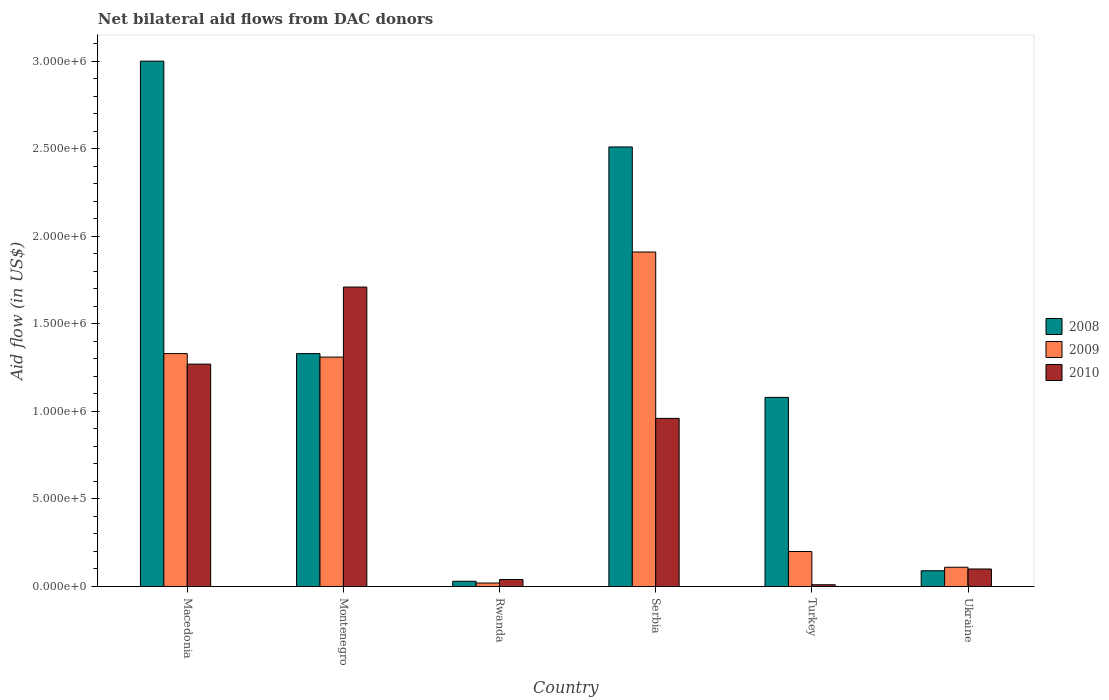How many different coloured bars are there?
Provide a succinct answer. 3. Are the number of bars on each tick of the X-axis equal?
Provide a succinct answer. Yes. How many bars are there on the 2nd tick from the left?
Provide a short and direct response. 3. What is the label of the 5th group of bars from the left?
Your answer should be very brief. Turkey. In how many cases, is the number of bars for a given country not equal to the number of legend labels?
Offer a very short reply. 0. Across all countries, what is the maximum net bilateral aid flow in 2009?
Your answer should be compact. 1.91e+06. Across all countries, what is the minimum net bilateral aid flow in 2009?
Your answer should be compact. 2.00e+04. In which country was the net bilateral aid flow in 2008 maximum?
Make the answer very short. Macedonia. What is the total net bilateral aid flow in 2010 in the graph?
Keep it short and to the point. 4.09e+06. What is the difference between the net bilateral aid flow in 2008 in Macedonia and that in Turkey?
Ensure brevity in your answer.  1.92e+06. What is the difference between the net bilateral aid flow in 2008 in Ukraine and the net bilateral aid flow in 2009 in Serbia?
Provide a succinct answer. -1.82e+06. What is the average net bilateral aid flow in 2008 per country?
Your answer should be very brief. 1.34e+06. What is the difference between the net bilateral aid flow of/in 2009 and net bilateral aid flow of/in 2008 in Rwanda?
Your answer should be very brief. -10000. In how many countries, is the net bilateral aid flow in 2009 greater than 700000 US$?
Offer a terse response. 3. What is the ratio of the net bilateral aid flow in 2009 in Rwanda to that in Ukraine?
Provide a succinct answer. 0.18. What is the difference between the highest and the second highest net bilateral aid flow in 2008?
Your answer should be very brief. 1.67e+06. What is the difference between the highest and the lowest net bilateral aid flow in 2009?
Provide a short and direct response. 1.89e+06. In how many countries, is the net bilateral aid flow in 2010 greater than the average net bilateral aid flow in 2010 taken over all countries?
Keep it short and to the point. 3. Is the sum of the net bilateral aid flow in 2008 in Montenegro and Serbia greater than the maximum net bilateral aid flow in 2009 across all countries?
Your response must be concise. Yes. What does the 3rd bar from the right in Macedonia represents?
Make the answer very short. 2008. Is it the case that in every country, the sum of the net bilateral aid flow in 2008 and net bilateral aid flow in 2010 is greater than the net bilateral aid flow in 2009?
Keep it short and to the point. Yes. How many bars are there?
Offer a terse response. 18. How many countries are there in the graph?
Keep it short and to the point. 6. What is the difference between two consecutive major ticks on the Y-axis?
Provide a succinct answer. 5.00e+05. Does the graph contain any zero values?
Offer a very short reply. No. Where does the legend appear in the graph?
Offer a very short reply. Center right. How many legend labels are there?
Your response must be concise. 3. How are the legend labels stacked?
Make the answer very short. Vertical. What is the title of the graph?
Make the answer very short. Net bilateral aid flows from DAC donors. Does "1975" appear as one of the legend labels in the graph?
Give a very brief answer. No. What is the label or title of the X-axis?
Provide a succinct answer. Country. What is the label or title of the Y-axis?
Your answer should be very brief. Aid flow (in US$). What is the Aid flow (in US$) of 2008 in Macedonia?
Provide a short and direct response. 3.00e+06. What is the Aid flow (in US$) of 2009 in Macedonia?
Provide a succinct answer. 1.33e+06. What is the Aid flow (in US$) in 2010 in Macedonia?
Provide a short and direct response. 1.27e+06. What is the Aid flow (in US$) in 2008 in Montenegro?
Make the answer very short. 1.33e+06. What is the Aid flow (in US$) in 2009 in Montenegro?
Your answer should be very brief. 1.31e+06. What is the Aid flow (in US$) of 2010 in Montenegro?
Offer a very short reply. 1.71e+06. What is the Aid flow (in US$) of 2008 in Serbia?
Make the answer very short. 2.51e+06. What is the Aid flow (in US$) of 2009 in Serbia?
Offer a very short reply. 1.91e+06. What is the Aid flow (in US$) in 2010 in Serbia?
Keep it short and to the point. 9.60e+05. What is the Aid flow (in US$) of 2008 in Turkey?
Your answer should be very brief. 1.08e+06. What is the Aid flow (in US$) in 2009 in Turkey?
Keep it short and to the point. 2.00e+05. What is the Aid flow (in US$) in 2010 in Turkey?
Ensure brevity in your answer.  10000. What is the Aid flow (in US$) in 2010 in Ukraine?
Provide a short and direct response. 1.00e+05. Across all countries, what is the maximum Aid flow (in US$) in 2009?
Make the answer very short. 1.91e+06. Across all countries, what is the maximum Aid flow (in US$) of 2010?
Provide a succinct answer. 1.71e+06. Across all countries, what is the minimum Aid flow (in US$) in 2010?
Your response must be concise. 10000. What is the total Aid flow (in US$) of 2008 in the graph?
Provide a short and direct response. 8.04e+06. What is the total Aid flow (in US$) in 2009 in the graph?
Provide a short and direct response. 4.88e+06. What is the total Aid flow (in US$) in 2010 in the graph?
Your response must be concise. 4.09e+06. What is the difference between the Aid flow (in US$) in 2008 in Macedonia and that in Montenegro?
Your answer should be compact. 1.67e+06. What is the difference between the Aid flow (in US$) of 2010 in Macedonia and that in Montenegro?
Give a very brief answer. -4.40e+05. What is the difference between the Aid flow (in US$) in 2008 in Macedonia and that in Rwanda?
Ensure brevity in your answer.  2.97e+06. What is the difference between the Aid flow (in US$) of 2009 in Macedonia and that in Rwanda?
Ensure brevity in your answer.  1.31e+06. What is the difference between the Aid flow (in US$) in 2010 in Macedonia and that in Rwanda?
Keep it short and to the point. 1.23e+06. What is the difference between the Aid flow (in US$) of 2008 in Macedonia and that in Serbia?
Your answer should be compact. 4.90e+05. What is the difference between the Aid flow (in US$) in 2009 in Macedonia and that in Serbia?
Keep it short and to the point. -5.80e+05. What is the difference between the Aid flow (in US$) in 2010 in Macedonia and that in Serbia?
Your answer should be very brief. 3.10e+05. What is the difference between the Aid flow (in US$) in 2008 in Macedonia and that in Turkey?
Provide a short and direct response. 1.92e+06. What is the difference between the Aid flow (in US$) in 2009 in Macedonia and that in Turkey?
Offer a terse response. 1.13e+06. What is the difference between the Aid flow (in US$) in 2010 in Macedonia and that in Turkey?
Keep it short and to the point. 1.26e+06. What is the difference between the Aid flow (in US$) in 2008 in Macedonia and that in Ukraine?
Your response must be concise. 2.91e+06. What is the difference between the Aid flow (in US$) of 2009 in Macedonia and that in Ukraine?
Give a very brief answer. 1.22e+06. What is the difference between the Aid flow (in US$) of 2010 in Macedonia and that in Ukraine?
Ensure brevity in your answer.  1.17e+06. What is the difference between the Aid flow (in US$) of 2008 in Montenegro and that in Rwanda?
Provide a succinct answer. 1.30e+06. What is the difference between the Aid flow (in US$) in 2009 in Montenegro and that in Rwanda?
Keep it short and to the point. 1.29e+06. What is the difference between the Aid flow (in US$) in 2010 in Montenegro and that in Rwanda?
Ensure brevity in your answer.  1.67e+06. What is the difference between the Aid flow (in US$) in 2008 in Montenegro and that in Serbia?
Offer a very short reply. -1.18e+06. What is the difference between the Aid flow (in US$) of 2009 in Montenegro and that in Serbia?
Offer a very short reply. -6.00e+05. What is the difference between the Aid flow (in US$) in 2010 in Montenegro and that in Serbia?
Your answer should be compact. 7.50e+05. What is the difference between the Aid flow (in US$) in 2008 in Montenegro and that in Turkey?
Your response must be concise. 2.50e+05. What is the difference between the Aid flow (in US$) of 2009 in Montenegro and that in Turkey?
Provide a succinct answer. 1.11e+06. What is the difference between the Aid flow (in US$) in 2010 in Montenegro and that in Turkey?
Offer a very short reply. 1.70e+06. What is the difference between the Aid flow (in US$) of 2008 in Montenegro and that in Ukraine?
Offer a very short reply. 1.24e+06. What is the difference between the Aid flow (in US$) of 2009 in Montenegro and that in Ukraine?
Give a very brief answer. 1.20e+06. What is the difference between the Aid flow (in US$) of 2010 in Montenegro and that in Ukraine?
Your answer should be very brief. 1.61e+06. What is the difference between the Aid flow (in US$) of 2008 in Rwanda and that in Serbia?
Your answer should be compact. -2.48e+06. What is the difference between the Aid flow (in US$) in 2009 in Rwanda and that in Serbia?
Your answer should be very brief. -1.89e+06. What is the difference between the Aid flow (in US$) of 2010 in Rwanda and that in Serbia?
Offer a terse response. -9.20e+05. What is the difference between the Aid flow (in US$) in 2008 in Rwanda and that in Turkey?
Make the answer very short. -1.05e+06. What is the difference between the Aid flow (in US$) in 2008 in Rwanda and that in Ukraine?
Provide a short and direct response. -6.00e+04. What is the difference between the Aid flow (in US$) of 2009 in Rwanda and that in Ukraine?
Make the answer very short. -9.00e+04. What is the difference between the Aid flow (in US$) of 2010 in Rwanda and that in Ukraine?
Ensure brevity in your answer.  -6.00e+04. What is the difference between the Aid flow (in US$) in 2008 in Serbia and that in Turkey?
Give a very brief answer. 1.43e+06. What is the difference between the Aid flow (in US$) of 2009 in Serbia and that in Turkey?
Give a very brief answer. 1.71e+06. What is the difference between the Aid flow (in US$) of 2010 in Serbia and that in Turkey?
Offer a very short reply. 9.50e+05. What is the difference between the Aid flow (in US$) of 2008 in Serbia and that in Ukraine?
Offer a very short reply. 2.42e+06. What is the difference between the Aid flow (in US$) in 2009 in Serbia and that in Ukraine?
Your response must be concise. 1.80e+06. What is the difference between the Aid flow (in US$) of 2010 in Serbia and that in Ukraine?
Offer a terse response. 8.60e+05. What is the difference between the Aid flow (in US$) of 2008 in Turkey and that in Ukraine?
Keep it short and to the point. 9.90e+05. What is the difference between the Aid flow (in US$) of 2010 in Turkey and that in Ukraine?
Provide a short and direct response. -9.00e+04. What is the difference between the Aid flow (in US$) in 2008 in Macedonia and the Aid flow (in US$) in 2009 in Montenegro?
Provide a short and direct response. 1.69e+06. What is the difference between the Aid flow (in US$) of 2008 in Macedonia and the Aid flow (in US$) of 2010 in Montenegro?
Make the answer very short. 1.29e+06. What is the difference between the Aid flow (in US$) of 2009 in Macedonia and the Aid flow (in US$) of 2010 in Montenegro?
Make the answer very short. -3.80e+05. What is the difference between the Aid flow (in US$) in 2008 in Macedonia and the Aid flow (in US$) in 2009 in Rwanda?
Your answer should be very brief. 2.98e+06. What is the difference between the Aid flow (in US$) in 2008 in Macedonia and the Aid flow (in US$) in 2010 in Rwanda?
Offer a very short reply. 2.96e+06. What is the difference between the Aid flow (in US$) in 2009 in Macedonia and the Aid flow (in US$) in 2010 in Rwanda?
Give a very brief answer. 1.29e+06. What is the difference between the Aid flow (in US$) in 2008 in Macedonia and the Aid flow (in US$) in 2009 in Serbia?
Your response must be concise. 1.09e+06. What is the difference between the Aid flow (in US$) of 2008 in Macedonia and the Aid flow (in US$) of 2010 in Serbia?
Offer a very short reply. 2.04e+06. What is the difference between the Aid flow (in US$) in 2009 in Macedonia and the Aid flow (in US$) in 2010 in Serbia?
Provide a short and direct response. 3.70e+05. What is the difference between the Aid flow (in US$) in 2008 in Macedonia and the Aid flow (in US$) in 2009 in Turkey?
Your answer should be very brief. 2.80e+06. What is the difference between the Aid flow (in US$) in 2008 in Macedonia and the Aid flow (in US$) in 2010 in Turkey?
Provide a succinct answer. 2.99e+06. What is the difference between the Aid flow (in US$) of 2009 in Macedonia and the Aid flow (in US$) of 2010 in Turkey?
Offer a terse response. 1.32e+06. What is the difference between the Aid flow (in US$) in 2008 in Macedonia and the Aid flow (in US$) in 2009 in Ukraine?
Provide a succinct answer. 2.89e+06. What is the difference between the Aid flow (in US$) of 2008 in Macedonia and the Aid flow (in US$) of 2010 in Ukraine?
Give a very brief answer. 2.90e+06. What is the difference between the Aid flow (in US$) in 2009 in Macedonia and the Aid flow (in US$) in 2010 in Ukraine?
Give a very brief answer. 1.23e+06. What is the difference between the Aid flow (in US$) in 2008 in Montenegro and the Aid flow (in US$) in 2009 in Rwanda?
Give a very brief answer. 1.31e+06. What is the difference between the Aid flow (in US$) of 2008 in Montenegro and the Aid flow (in US$) of 2010 in Rwanda?
Your answer should be compact. 1.29e+06. What is the difference between the Aid flow (in US$) of 2009 in Montenegro and the Aid flow (in US$) of 2010 in Rwanda?
Offer a very short reply. 1.27e+06. What is the difference between the Aid flow (in US$) in 2008 in Montenegro and the Aid flow (in US$) in 2009 in Serbia?
Provide a short and direct response. -5.80e+05. What is the difference between the Aid flow (in US$) in 2008 in Montenegro and the Aid flow (in US$) in 2010 in Serbia?
Make the answer very short. 3.70e+05. What is the difference between the Aid flow (in US$) of 2008 in Montenegro and the Aid flow (in US$) of 2009 in Turkey?
Offer a terse response. 1.13e+06. What is the difference between the Aid flow (in US$) in 2008 in Montenegro and the Aid flow (in US$) in 2010 in Turkey?
Your answer should be very brief. 1.32e+06. What is the difference between the Aid flow (in US$) in 2009 in Montenegro and the Aid flow (in US$) in 2010 in Turkey?
Your answer should be compact. 1.30e+06. What is the difference between the Aid flow (in US$) of 2008 in Montenegro and the Aid flow (in US$) of 2009 in Ukraine?
Provide a short and direct response. 1.22e+06. What is the difference between the Aid flow (in US$) in 2008 in Montenegro and the Aid flow (in US$) in 2010 in Ukraine?
Provide a succinct answer. 1.23e+06. What is the difference between the Aid flow (in US$) in 2009 in Montenegro and the Aid flow (in US$) in 2010 in Ukraine?
Give a very brief answer. 1.21e+06. What is the difference between the Aid flow (in US$) in 2008 in Rwanda and the Aid flow (in US$) in 2009 in Serbia?
Keep it short and to the point. -1.88e+06. What is the difference between the Aid flow (in US$) in 2008 in Rwanda and the Aid flow (in US$) in 2010 in Serbia?
Offer a very short reply. -9.30e+05. What is the difference between the Aid flow (in US$) in 2009 in Rwanda and the Aid flow (in US$) in 2010 in Serbia?
Your answer should be compact. -9.40e+05. What is the difference between the Aid flow (in US$) in 2009 in Rwanda and the Aid flow (in US$) in 2010 in Turkey?
Offer a terse response. 10000. What is the difference between the Aid flow (in US$) in 2008 in Rwanda and the Aid flow (in US$) in 2010 in Ukraine?
Offer a terse response. -7.00e+04. What is the difference between the Aid flow (in US$) in 2008 in Serbia and the Aid flow (in US$) in 2009 in Turkey?
Your response must be concise. 2.31e+06. What is the difference between the Aid flow (in US$) in 2008 in Serbia and the Aid flow (in US$) in 2010 in Turkey?
Provide a short and direct response. 2.50e+06. What is the difference between the Aid flow (in US$) of 2009 in Serbia and the Aid flow (in US$) of 2010 in Turkey?
Make the answer very short. 1.90e+06. What is the difference between the Aid flow (in US$) in 2008 in Serbia and the Aid flow (in US$) in 2009 in Ukraine?
Make the answer very short. 2.40e+06. What is the difference between the Aid flow (in US$) of 2008 in Serbia and the Aid flow (in US$) of 2010 in Ukraine?
Your response must be concise. 2.41e+06. What is the difference between the Aid flow (in US$) of 2009 in Serbia and the Aid flow (in US$) of 2010 in Ukraine?
Provide a succinct answer. 1.81e+06. What is the difference between the Aid flow (in US$) of 2008 in Turkey and the Aid flow (in US$) of 2009 in Ukraine?
Provide a succinct answer. 9.70e+05. What is the difference between the Aid flow (in US$) in 2008 in Turkey and the Aid flow (in US$) in 2010 in Ukraine?
Give a very brief answer. 9.80e+05. What is the average Aid flow (in US$) in 2008 per country?
Offer a terse response. 1.34e+06. What is the average Aid flow (in US$) in 2009 per country?
Keep it short and to the point. 8.13e+05. What is the average Aid flow (in US$) of 2010 per country?
Your answer should be very brief. 6.82e+05. What is the difference between the Aid flow (in US$) of 2008 and Aid flow (in US$) of 2009 in Macedonia?
Ensure brevity in your answer.  1.67e+06. What is the difference between the Aid flow (in US$) in 2008 and Aid flow (in US$) in 2010 in Macedonia?
Give a very brief answer. 1.73e+06. What is the difference between the Aid flow (in US$) of 2008 and Aid flow (in US$) of 2010 in Montenegro?
Offer a terse response. -3.80e+05. What is the difference between the Aid flow (in US$) in 2009 and Aid flow (in US$) in 2010 in Montenegro?
Make the answer very short. -4.00e+05. What is the difference between the Aid flow (in US$) of 2008 and Aid flow (in US$) of 2009 in Rwanda?
Give a very brief answer. 10000. What is the difference between the Aid flow (in US$) of 2009 and Aid flow (in US$) of 2010 in Rwanda?
Provide a succinct answer. -2.00e+04. What is the difference between the Aid flow (in US$) of 2008 and Aid flow (in US$) of 2010 in Serbia?
Your answer should be compact. 1.55e+06. What is the difference between the Aid flow (in US$) in 2009 and Aid flow (in US$) in 2010 in Serbia?
Your answer should be compact. 9.50e+05. What is the difference between the Aid flow (in US$) in 2008 and Aid flow (in US$) in 2009 in Turkey?
Offer a very short reply. 8.80e+05. What is the difference between the Aid flow (in US$) of 2008 and Aid flow (in US$) of 2010 in Turkey?
Offer a terse response. 1.07e+06. What is the difference between the Aid flow (in US$) in 2009 and Aid flow (in US$) in 2010 in Turkey?
Provide a succinct answer. 1.90e+05. What is the difference between the Aid flow (in US$) in 2008 and Aid flow (in US$) in 2009 in Ukraine?
Make the answer very short. -2.00e+04. What is the ratio of the Aid flow (in US$) in 2008 in Macedonia to that in Montenegro?
Give a very brief answer. 2.26. What is the ratio of the Aid flow (in US$) in 2009 in Macedonia to that in Montenegro?
Your response must be concise. 1.02. What is the ratio of the Aid flow (in US$) in 2010 in Macedonia to that in Montenegro?
Your answer should be very brief. 0.74. What is the ratio of the Aid flow (in US$) of 2008 in Macedonia to that in Rwanda?
Keep it short and to the point. 100. What is the ratio of the Aid flow (in US$) of 2009 in Macedonia to that in Rwanda?
Your answer should be compact. 66.5. What is the ratio of the Aid flow (in US$) of 2010 in Macedonia to that in Rwanda?
Keep it short and to the point. 31.75. What is the ratio of the Aid flow (in US$) in 2008 in Macedonia to that in Serbia?
Your answer should be compact. 1.2. What is the ratio of the Aid flow (in US$) of 2009 in Macedonia to that in Serbia?
Ensure brevity in your answer.  0.7. What is the ratio of the Aid flow (in US$) in 2010 in Macedonia to that in Serbia?
Provide a short and direct response. 1.32. What is the ratio of the Aid flow (in US$) of 2008 in Macedonia to that in Turkey?
Your answer should be compact. 2.78. What is the ratio of the Aid flow (in US$) of 2009 in Macedonia to that in Turkey?
Make the answer very short. 6.65. What is the ratio of the Aid flow (in US$) in 2010 in Macedonia to that in Turkey?
Keep it short and to the point. 127. What is the ratio of the Aid flow (in US$) of 2008 in Macedonia to that in Ukraine?
Keep it short and to the point. 33.33. What is the ratio of the Aid flow (in US$) in 2009 in Macedonia to that in Ukraine?
Provide a succinct answer. 12.09. What is the ratio of the Aid flow (in US$) in 2008 in Montenegro to that in Rwanda?
Offer a terse response. 44.33. What is the ratio of the Aid flow (in US$) of 2009 in Montenegro to that in Rwanda?
Provide a short and direct response. 65.5. What is the ratio of the Aid flow (in US$) in 2010 in Montenegro to that in Rwanda?
Keep it short and to the point. 42.75. What is the ratio of the Aid flow (in US$) of 2008 in Montenegro to that in Serbia?
Your answer should be very brief. 0.53. What is the ratio of the Aid flow (in US$) in 2009 in Montenegro to that in Serbia?
Your answer should be compact. 0.69. What is the ratio of the Aid flow (in US$) in 2010 in Montenegro to that in Serbia?
Provide a succinct answer. 1.78. What is the ratio of the Aid flow (in US$) of 2008 in Montenegro to that in Turkey?
Your response must be concise. 1.23. What is the ratio of the Aid flow (in US$) of 2009 in Montenegro to that in Turkey?
Your answer should be compact. 6.55. What is the ratio of the Aid flow (in US$) of 2010 in Montenegro to that in Turkey?
Keep it short and to the point. 171. What is the ratio of the Aid flow (in US$) of 2008 in Montenegro to that in Ukraine?
Your answer should be compact. 14.78. What is the ratio of the Aid flow (in US$) in 2009 in Montenegro to that in Ukraine?
Offer a very short reply. 11.91. What is the ratio of the Aid flow (in US$) of 2010 in Montenegro to that in Ukraine?
Keep it short and to the point. 17.1. What is the ratio of the Aid flow (in US$) in 2008 in Rwanda to that in Serbia?
Ensure brevity in your answer.  0.01. What is the ratio of the Aid flow (in US$) of 2009 in Rwanda to that in Serbia?
Ensure brevity in your answer.  0.01. What is the ratio of the Aid flow (in US$) of 2010 in Rwanda to that in Serbia?
Your answer should be compact. 0.04. What is the ratio of the Aid flow (in US$) in 2008 in Rwanda to that in Turkey?
Offer a very short reply. 0.03. What is the ratio of the Aid flow (in US$) of 2010 in Rwanda to that in Turkey?
Keep it short and to the point. 4. What is the ratio of the Aid flow (in US$) in 2008 in Rwanda to that in Ukraine?
Give a very brief answer. 0.33. What is the ratio of the Aid flow (in US$) in 2009 in Rwanda to that in Ukraine?
Make the answer very short. 0.18. What is the ratio of the Aid flow (in US$) in 2010 in Rwanda to that in Ukraine?
Offer a terse response. 0.4. What is the ratio of the Aid flow (in US$) in 2008 in Serbia to that in Turkey?
Your answer should be very brief. 2.32. What is the ratio of the Aid flow (in US$) of 2009 in Serbia to that in Turkey?
Your answer should be compact. 9.55. What is the ratio of the Aid flow (in US$) in 2010 in Serbia to that in Turkey?
Provide a short and direct response. 96. What is the ratio of the Aid flow (in US$) in 2008 in Serbia to that in Ukraine?
Your answer should be very brief. 27.89. What is the ratio of the Aid flow (in US$) in 2009 in Serbia to that in Ukraine?
Offer a terse response. 17.36. What is the ratio of the Aid flow (in US$) of 2010 in Serbia to that in Ukraine?
Keep it short and to the point. 9.6. What is the ratio of the Aid flow (in US$) of 2008 in Turkey to that in Ukraine?
Your answer should be compact. 12. What is the ratio of the Aid flow (in US$) of 2009 in Turkey to that in Ukraine?
Your answer should be compact. 1.82. What is the difference between the highest and the second highest Aid flow (in US$) of 2008?
Your response must be concise. 4.90e+05. What is the difference between the highest and the second highest Aid flow (in US$) of 2009?
Ensure brevity in your answer.  5.80e+05. What is the difference between the highest and the lowest Aid flow (in US$) of 2008?
Make the answer very short. 2.97e+06. What is the difference between the highest and the lowest Aid flow (in US$) of 2009?
Make the answer very short. 1.89e+06. What is the difference between the highest and the lowest Aid flow (in US$) of 2010?
Provide a succinct answer. 1.70e+06. 